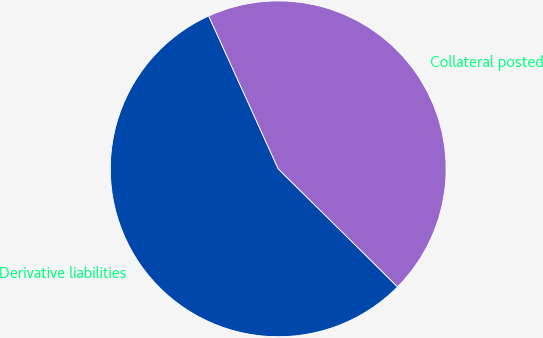<chart> <loc_0><loc_0><loc_500><loc_500><pie_chart><fcel>Derivative liabilities<fcel>Collateral posted<nl><fcel>55.8%<fcel>44.2%<nl></chart> 